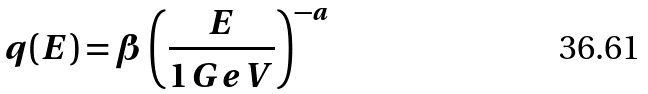<formula> <loc_0><loc_0><loc_500><loc_500>q ( E ) = \beta \left ( \frac { E } { 1 \, G e V } \right ) ^ { - a }</formula> 